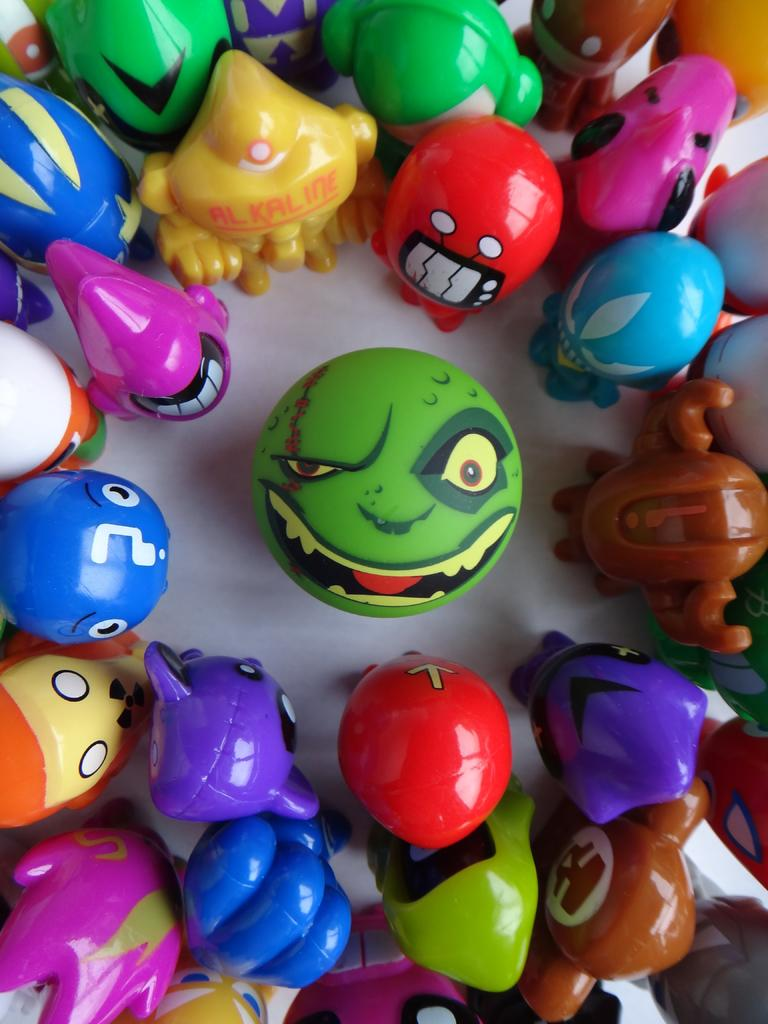What type of objects can be seen in the image? There are colorful toys in the image. Can you identify a specific type of toy in the image? Yes, there is a ball in the image. What type of learning is taking place in the image? There is no indication of any learning taking place in the image; it simply features colorful toys and a ball. What is the mass of the ball in the image? The mass of the ball cannot be determined from the image alone, as it requires specific measurements and tools. 